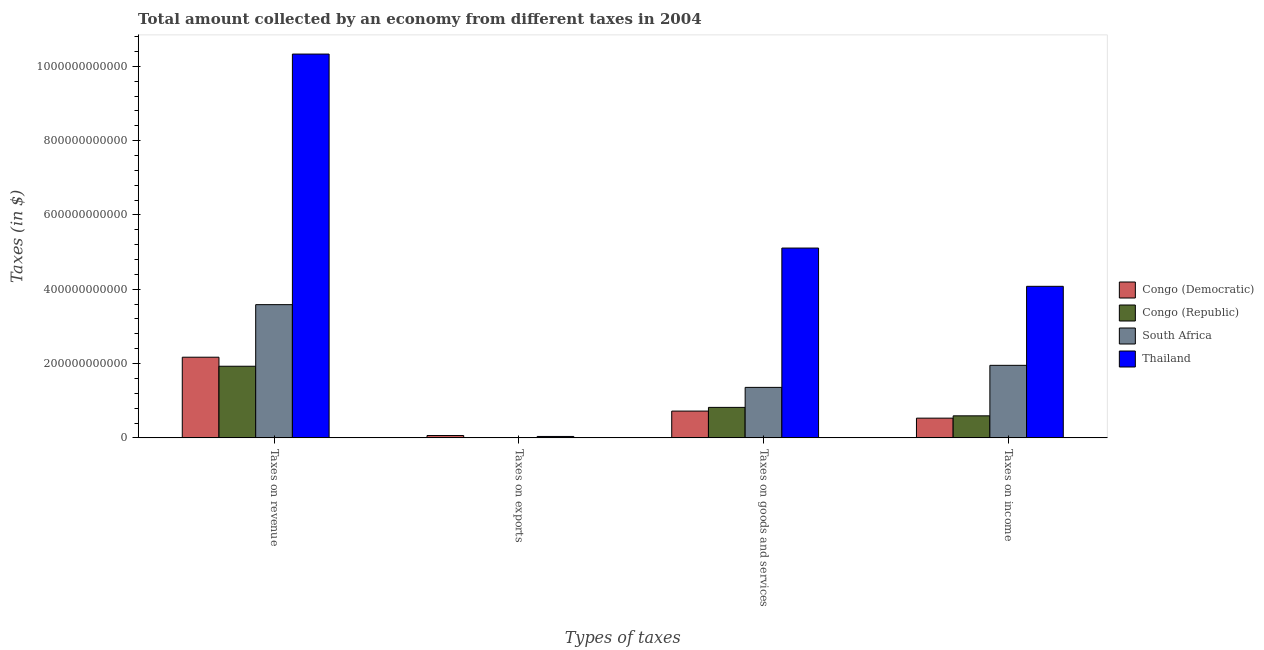How many different coloured bars are there?
Ensure brevity in your answer.  4. How many groups of bars are there?
Give a very brief answer. 4. Are the number of bars per tick equal to the number of legend labels?
Provide a short and direct response. Yes. How many bars are there on the 2nd tick from the left?
Keep it short and to the point. 4. How many bars are there on the 1st tick from the right?
Provide a short and direct response. 4. What is the label of the 3rd group of bars from the left?
Provide a succinct answer. Taxes on goods and services. What is the amount collected as tax on income in Congo (Democratic)?
Offer a terse response. 5.31e+1. Across all countries, what is the maximum amount collected as tax on goods?
Provide a short and direct response. 5.11e+11. Across all countries, what is the minimum amount collected as tax on income?
Ensure brevity in your answer.  5.31e+1. In which country was the amount collected as tax on income maximum?
Ensure brevity in your answer.  Thailand. In which country was the amount collected as tax on goods minimum?
Provide a short and direct response. Congo (Democratic). What is the total amount collected as tax on goods in the graph?
Provide a succinct answer. 8.01e+11. What is the difference between the amount collected as tax on exports in South Africa and that in Congo (Republic)?
Keep it short and to the point. -9.62e+07. What is the difference between the amount collected as tax on revenue in Congo (Democratic) and the amount collected as tax on exports in Thailand?
Offer a very short reply. 2.13e+11. What is the average amount collected as tax on goods per country?
Provide a succinct answer. 2.00e+11. What is the difference between the amount collected as tax on goods and amount collected as tax on revenue in Congo (Democratic)?
Keep it short and to the point. -1.45e+11. In how many countries, is the amount collected as tax on revenue greater than 360000000000 $?
Ensure brevity in your answer.  1. What is the ratio of the amount collected as tax on income in South Africa to that in Congo (Democratic)?
Provide a short and direct response. 3.68. Is the amount collected as tax on exports in Congo (Republic) less than that in Congo (Democratic)?
Make the answer very short. Yes. What is the difference between the highest and the second highest amount collected as tax on revenue?
Provide a succinct answer. 6.74e+11. What is the difference between the highest and the lowest amount collected as tax on goods?
Provide a short and direct response. 4.39e+11. In how many countries, is the amount collected as tax on income greater than the average amount collected as tax on income taken over all countries?
Offer a terse response. 2. Is it the case that in every country, the sum of the amount collected as tax on goods and amount collected as tax on revenue is greater than the sum of amount collected as tax on exports and amount collected as tax on income?
Your answer should be compact. Yes. What does the 2nd bar from the left in Taxes on exports represents?
Your response must be concise. Congo (Republic). What does the 2nd bar from the right in Taxes on exports represents?
Ensure brevity in your answer.  South Africa. Are all the bars in the graph horizontal?
Keep it short and to the point. No. How many countries are there in the graph?
Give a very brief answer. 4. What is the difference between two consecutive major ticks on the Y-axis?
Provide a succinct answer. 2.00e+11. Does the graph contain any zero values?
Provide a succinct answer. No. Does the graph contain grids?
Provide a succinct answer. No. Where does the legend appear in the graph?
Make the answer very short. Center right. How are the legend labels stacked?
Offer a very short reply. Vertical. What is the title of the graph?
Offer a very short reply. Total amount collected by an economy from different taxes in 2004. What is the label or title of the X-axis?
Ensure brevity in your answer.  Types of taxes. What is the label or title of the Y-axis?
Keep it short and to the point. Taxes (in $). What is the Taxes (in $) of Congo (Democratic) in Taxes on revenue?
Offer a terse response. 2.17e+11. What is the Taxes (in $) of Congo (Republic) in Taxes on revenue?
Keep it short and to the point. 1.93e+11. What is the Taxes (in $) of South Africa in Taxes on revenue?
Make the answer very short. 3.59e+11. What is the Taxes (in $) in Thailand in Taxes on revenue?
Your answer should be very brief. 1.03e+12. What is the Taxes (in $) of Congo (Democratic) in Taxes on exports?
Provide a succinct answer. 6.33e+09. What is the Taxes (in $) of Congo (Republic) in Taxes on exports?
Make the answer very short. 9.72e+07. What is the Taxes (in $) in South Africa in Taxes on exports?
Your answer should be very brief. 1.00e+06. What is the Taxes (in $) in Thailand in Taxes on exports?
Keep it short and to the point. 3.79e+09. What is the Taxes (in $) in Congo (Democratic) in Taxes on goods and services?
Offer a terse response. 7.21e+1. What is the Taxes (in $) of Congo (Republic) in Taxes on goods and services?
Offer a very short reply. 8.21e+1. What is the Taxes (in $) of South Africa in Taxes on goods and services?
Make the answer very short. 1.36e+11. What is the Taxes (in $) of Thailand in Taxes on goods and services?
Offer a very short reply. 5.11e+11. What is the Taxes (in $) in Congo (Democratic) in Taxes on income?
Provide a short and direct response. 5.31e+1. What is the Taxes (in $) of Congo (Republic) in Taxes on income?
Your response must be concise. 5.93e+1. What is the Taxes (in $) of South Africa in Taxes on income?
Your answer should be compact. 1.95e+11. What is the Taxes (in $) of Thailand in Taxes on income?
Provide a succinct answer. 4.08e+11. Across all Types of taxes, what is the maximum Taxes (in $) of Congo (Democratic)?
Your response must be concise. 2.17e+11. Across all Types of taxes, what is the maximum Taxes (in $) of Congo (Republic)?
Make the answer very short. 1.93e+11. Across all Types of taxes, what is the maximum Taxes (in $) in South Africa?
Your answer should be compact. 3.59e+11. Across all Types of taxes, what is the maximum Taxes (in $) in Thailand?
Make the answer very short. 1.03e+12. Across all Types of taxes, what is the minimum Taxes (in $) of Congo (Democratic)?
Your response must be concise. 6.33e+09. Across all Types of taxes, what is the minimum Taxes (in $) in Congo (Republic)?
Ensure brevity in your answer.  9.72e+07. Across all Types of taxes, what is the minimum Taxes (in $) of Thailand?
Your response must be concise. 3.79e+09. What is the total Taxes (in $) in Congo (Democratic) in the graph?
Provide a short and direct response. 3.49e+11. What is the total Taxes (in $) in Congo (Republic) in the graph?
Your response must be concise. 3.34e+11. What is the total Taxes (in $) of South Africa in the graph?
Offer a very short reply. 6.90e+11. What is the total Taxes (in $) in Thailand in the graph?
Your response must be concise. 1.96e+12. What is the difference between the Taxes (in $) of Congo (Democratic) in Taxes on revenue and that in Taxes on exports?
Provide a succinct answer. 2.11e+11. What is the difference between the Taxes (in $) in Congo (Republic) in Taxes on revenue and that in Taxes on exports?
Offer a terse response. 1.93e+11. What is the difference between the Taxes (in $) in South Africa in Taxes on revenue and that in Taxes on exports?
Provide a short and direct response. 3.59e+11. What is the difference between the Taxes (in $) in Thailand in Taxes on revenue and that in Taxes on exports?
Your answer should be very brief. 1.03e+12. What is the difference between the Taxes (in $) in Congo (Democratic) in Taxes on revenue and that in Taxes on goods and services?
Make the answer very short. 1.45e+11. What is the difference between the Taxes (in $) in Congo (Republic) in Taxes on revenue and that in Taxes on goods and services?
Ensure brevity in your answer.  1.11e+11. What is the difference between the Taxes (in $) of South Africa in Taxes on revenue and that in Taxes on goods and services?
Offer a very short reply. 2.23e+11. What is the difference between the Taxes (in $) of Thailand in Taxes on revenue and that in Taxes on goods and services?
Offer a terse response. 5.22e+11. What is the difference between the Taxes (in $) in Congo (Democratic) in Taxes on revenue and that in Taxes on income?
Provide a short and direct response. 1.64e+11. What is the difference between the Taxes (in $) in Congo (Republic) in Taxes on revenue and that in Taxes on income?
Offer a terse response. 1.33e+11. What is the difference between the Taxes (in $) of South Africa in Taxes on revenue and that in Taxes on income?
Provide a short and direct response. 1.63e+11. What is the difference between the Taxes (in $) in Thailand in Taxes on revenue and that in Taxes on income?
Provide a succinct answer. 6.25e+11. What is the difference between the Taxes (in $) of Congo (Democratic) in Taxes on exports and that in Taxes on goods and services?
Your response must be concise. -6.58e+1. What is the difference between the Taxes (in $) of Congo (Republic) in Taxes on exports and that in Taxes on goods and services?
Your answer should be very brief. -8.20e+1. What is the difference between the Taxes (in $) of South Africa in Taxes on exports and that in Taxes on goods and services?
Offer a very short reply. -1.36e+11. What is the difference between the Taxes (in $) of Thailand in Taxes on exports and that in Taxes on goods and services?
Ensure brevity in your answer.  -5.07e+11. What is the difference between the Taxes (in $) of Congo (Democratic) in Taxes on exports and that in Taxes on income?
Offer a very short reply. -4.68e+1. What is the difference between the Taxes (in $) of Congo (Republic) in Taxes on exports and that in Taxes on income?
Offer a very short reply. -5.92e+1. What is the difference between the Taxes (in $) in South Africa in Taxes on exports and that in Taxes on income?
Provide a succinct answer. -1.95e+11. What is the difference between the Taxes (in $) in Thailand in Taxes on exports and that in Taxes on income?
Provide a succinct answer. -4.04e+11. What is the difference between the Taxes (in $) of Congo (Democratic) in Taxes on goods and services and that in Taxes on income?
Offer a terse response. 1.90e+1. What is the difference between the Taxes (in $) of Congo (Republic) in Taxes on goods and services and that in Taxes on income?
Provide a short and direct response. 2.28e+1. What is the difference between the Taxes (in $) of South Africa in Taxes on goods and services and that in Taxes on income?
Your answer should be very brief. -5.94e+1. What is the difference between the Taxes (in $) in Thailand in Taxes on goods and services and that in Taxes on income?
Your answer should be very brief. 1.03e+11. What is the difference between the Taxes (in $) of Congo (Democratic) in Taxes on revenue and the Taxes (in $) of Congo (Republic) in Taxes on exports?
Give a very brief answer. 2.17e+11. What is the difference between the Taxes (in $) of Congo (Democratic) in Taxes on revenue and the Taxes (in $) of South Africa in Taxes on exports?
Your answer should be compact. 2.17e+11. What is the difference between the Taxes (in $) in Congo (Democratic) in Taxes on revenue and the Taxes (in $) in Thailand in Taxes on exports?
Your answer should be compact. 2.13e+11. What is the difference between the Taxes (in $) in Congo (Republic) in Taxes on revenue and the Taxes (in $) in South Africa in Taxes on exports?
Offer a terse response. 1.93e+11. What is the difference between the Taxes (in $) in Congo (Republic) in Taxes on revenue and the Taxes (in $) in Thailand in Taxes on exports?
Provide a succinct answer. 1.89e+11. What is the difference between the Taxes (in $) in South Africa in Taxes on revenue and the Taxes (in $) in Thailand in Taxes on exports?
Give a very brief answer. 3.55e+11. What is the difference between the Taxes (in $) in Congo (Democratic) in Taxes on revenue and the Taxes (in $) in Congo (Republic) in Taxes on goods and services?
Give a very brief answer. 1.35e+11. What is the difference between the Taxes (in $) in Congo (Democratic) in Taxes on revenue and the Taxes (in $) in South Africa in Taxes on goods and services?
Keep it short and to the point. 8.12e+1. What is the difference between the Taxes (in $) of Congo (Democratic) in Taxes on revenue and the Taxes (in $) of Thailand in Taxes on goods and services?
Give a very brief answer. -2.94e+11. What is the difference between the Taxes (in $) in Congo (Republic) in Taxes on revenue and the Taxes (in $) in South Africa in Taxes on goods and services?
Ensure brevity in your answer.  5.69e+1. What is the difference between the Taxes (in $) in Congo (Republic) in Taxes on revenue and the Taxes (in $) in Thailand in Taxes on goods and services?
Provide a short and direct response. -3.18e+11. What is the difference between the Taxes (in $) in South Africa in Taxes on revenue and the Taxes (in $) in Thailand in Taxes on goods and services?
Provide a short and direct response. -1.52e+11. What is the difference between the Taxes (in $) in Congo (Democratic) in Taxes on revenue and the Taxes (in $) in Congo (Republic) in Taxes on income?
Give a very brief answer. 1.58e+11. What is the difference between the Taxes (in $) of Congo (Democratic) in Taxes on revenue and the Taxes (in $) of South Africa in Taxes on income?
Your answer should be very brief. 2.18e+1. What is the difference between the Taxes (in $) in Congo (Democratic) in Taxes on revenue and the Taxes (in $) in Thailand in Taxes on income?
Keep it short and to the point. -1.91e+11. What is the difference between the Taxes (in $) of Congo (Republic) in Taxes on revenue and the Taxes (in $) of South Africa in Taxes on income?
Offer a terse response. -2.46e+09. What is the difference between the Taxes (in $) of Congo (Republic) in Taxes on revenue and the Taxes (in $) of Thailand in Taxes on income?
Provide a short and direct response. -2.15e+11. What is the difference between the Taxes (in $) of South Africa in Taxes on revenue and the Taxes (in $) of Thailand in Taxes on income?
Give a very brief answer. -4.93e+1. What is the difference between the Taxes (in $) in Congo (Democratic) in Taxes on exports and the Taxes (in $) in Congo (Republic) in Taxes on goods and services?
Your answer should be compact. -7.57e+1. What is the difference between the Taxes (in $) in Congo (Democratic) in Taxes on exports and the Taxes (in $) in South Africa in Taxes on goods and services?
Your response must be concise. -1.30e+11. What is the difference between the Taxes (in $) in Congo (Democratic) in Taxes on exports and the Taxes (in $) in Thailand in Taxes on goods and services?
Make the answer very short. -5.05e+11. What is the difference between the Taxes (in $) in Congo (Republic) in Taxes on exports and the Taxes (in $) in South Africa in Taxes on goods and services?
Offer a terse response. -1.36e+11. What is the difference between the Taxes (in $) in Congo (Republic) in Taxes on exports and the Taxes (in $) in Thailand in Taxes on goods and services?
Provide a short and direct response. -5.11e+11. What is the difference between the Taxes (in $) in South Africa in Taxes on exports and the Taxes (in $) in Thailand in Taxes on goods and services?
Your answer should be very brief. -5.11e+11. What is the difference between the Taxes (in $) of Congo (Democratic) in Taxes on exports and the Taxes (in $) of Congo (Republic) in Taxes on income?
Give a very brief answer. -5.30e+1. What is the difference between the Taxes (in $) in Congo (Democratic) in Taxes on exports and the Taxes (in $) in South Africa in Taxes on income?
Provide a succinct answer. -1.89e+11. What is the difference between the Taxes (in $) of Congo (Democratic) in Taxes on exports and the Taxes (in $) of Thailand in Taxes on income?
Your answer should be very brief. -4.02e+11. What is the difference between the Taxes (in $) in Congo (Republic) in Taxes on exports and the Taxes (in $) in South Africa in Taxes on income?
Keep it short and to the point. -1.95e+11. What is the difference between the Taxes (in $) in Congo (Republic) in Taxes on exports and the Taxes (in $) in Thailand in Taxes on income?
Offer a terse response. -4.08e+11. What is the difference between the Taxes (in $) of South Africa in Taxes on exports and the Taxes (in $) of Thailand in Taxes on income?
Keep it short and to the point. -4.08e+11. What is the difference between the Taxes (in $) of Congo (Democratic) in Taxes on goods and services and the Taxes (in $) of Congo (Republic) in Taxes on income?
Provide a succinct answer. 1.28e+1. What is the difference between the Taxes (in $) in Congo (Democratic) in Taxes on goods and services and the Taxes (in $) in South Africa in Taxes on income?
Offer a very short reply. -1.23e+11. What is the difference between the Taxes (in $) of Congo (Democratic) in Taxes on goods and services and the Taxes (in $) of Thailand in Taxes on income?
Your answer should be very brief. -3.36e+11. What is the difference between the Taxes (in $) of Congo (Republic) in Taxes on goods and services and the Taxes (in $) of South Africa in Taxes on income?
Offer a terse response. -1.13e+11. What is the difference between the Taxes (in $) of Congo (Republic) in Taxes on goods and services and the Taxes (in $) of Thailand in Taxes on income?
Make the answer very short. -3.26e+11. What is the difference between the Taxes (in $) in South Africa in Taxes on goods and services and the Taxes (in $) in Thailand in Taxes on income?
Provide a short and direct response. -2.72e+11. What is the average Taxes (in $) of Congo (Democratic) per Types of taxes?
Make the answer very short. 8.71e+1. What is the average Taxes (in $) of Congo (Republic) per Types of taxes?
Provide a short and direct response. 8.36e+1. What is the average Taxes (in $) of South Africa per Types of taxes?
Make the answer very short. 1.72e+11. What is the average Taxes (in $) in Thailand per Types of taxes?
Give a very brief answer. 4.89e+11. What is the difference between the Taxes (in $) in Congo (Democratic) and Taxes (in $) in Congo (Republic) in Taxes on revenue?
Offer a very short reply. 2.43e+1. What is the difference between the Taxes (in $) of Congo (Democratic) and Taxes (in $) of South Africa in Taxes on revenue?
Offer a very short reply. -1.41e+11. What is the difference between the Taxes (in $) in Congo (Democratic) and Taxes (in $) in Thailand in Taxes on revenue?
Your answer should be very brief. -8.16e+11. What is the difference between the Taxes (in $) in Congo (Republic) and Taxes (in $) in South Africa in Taxes on revenue?
Make the answer very short. -1.66e+11. What is the difference between the Taxes (in $) in Congo (Republic) and Taxes (in $) in Thailand in Taxes on revenue?
Make the answer very short. -8.40e+11. What is the difference between the Taxes (in $) in South Africa and Taxes (in $) in Thailand in Taxes on revenue?
Ensure brevity in your answer.  -6.74e+11. What is the difference between the Taxes (in $) of Congo (Democratic) and Taxes (in $) of Congo (Republic) in Taxes on exports?
Provide a succinct answer. 6.23e+09. What is the difference between the Taxes (in $) in Congo (Democratic) and Taxes (in $) in South Africa in Taxes on exports?
Your response must be concise. 6.32e+09. What is the difference between the Taxes (in $) of Congo (Democratic) and Taxes (in $) of Thailand in Taxes on exports?
Offer a very short reply. 2.54e+09. What is the difference between the Taxes (in $) of Congo (Republic) and Taxes (in $) of South Africa in Taxes on exports?
Offer a terse response. 9.62e+07. What is the difference between the Taxes (in $) of Congo (Republic) and Taxes (in $) of Thailand in Taxes on exports?
Your answer should be compact. -3.69e+09. What is the difference between the Taxes (in $) of South Africa and Taxes (in $) of Thailand in Taxes on exports?
Make the answer very short. -3.79e+09. What is the difference between the Taxes (in $) of Congo (Democratic) and Taxes (in $) of Congo (Republic) in Taxes on goods and services?
Ensure brevity in your answer.  -9.97e+09. What is the difference between the Taxes (in $) of Congo (Democratic) and Taxes (in $) of South Africa in Taxes on goods and services?
Make the answer very short. -6.38e+1. What is the difference between the Taxes (in $) of Congo (Democratic) and Taxes (in $) of Thailand in Taxes on goods and services?
Your answer should be compact. -4.39e+11. What is the difference between the Taxes (in $) of Congo (Republic) and Taxes (in $) of South Africa in Taxes on goods and services?
Provide a short and direct response. -5.38e+1. What is the difference between the Taxes (in $) of Congo (Republic) and Taxes (in $) of Thailand in Taxes on goods and services?
Provide a succinct answer. -4.29e+11. What is the difference between the Taxes (in $) in South Africa and Taxes (in $) in Thailand in Taxes on goods and services?
Keep it short and to the point. -3.75e+11. What is the difference between the Taxes (in $) of Congo (Democratic) and Taxes (in $) of Congo (Republic) in Taxes on income?
Ensure brevity in your answer.  -6.23e+09. What is the difference between the Taxes (in $) in Congo (Democratic) and Taxes (in $) in South Africa in Taxes on income?
Offer a terse response. -1.42e+11. What is the difference between the Taxes (in $) in Congo (Democratic) and Taxes (in $) in Thailand in Taxes on income?
Give a very brief answer. -3.55e+11. What is the difference between the Taxes (in $) of Congo (Republic) and Taxes (in $) of South Africa in Taxes on income?
Ensure brevity in your answer.  -1.36e+11. What is the difference between the Taxes (in $) in Congo (Republic) and Taxes (in $) in Thailand in Taxes on income?
Provide a succinct answer. -3.49e+11. What is the difference between the Taxes (in $) in South Africa and Taxes (in $) in Thailand in Taxes on income?
Your response must be concise. -2.13e+11. What is the ratio of the Taxes (in $) in Congo (Democratic) in Taxes on revenue to that in Taxes on exports?
Your response must be concise. 34.32. What is the ratio of the Taxes (in $) of Congo (Republic) in Taxes on revenue to that in Taxes on exports?
Offer a very short reply. 1983.41. What is the ratio of the Taxes (in $) of South Africa in Taxes on revenue to that in Taxes on exports?
Your answer should be compact. 3.59e+05. What is the ratio of the Taxes (in $) in Thailand in Taxes on revenue to that in Taxes on exports?
Make the answer very short. 272.75. What is the ratio of the Taxes (in $) in Congo (Democratic) in Taxes on revenue to that in Taxes on goods and services?
Give a very brief answer. 3.01. What is the ratio of the Taxes (in $) of Congo (Republic) in Taxes on revenue to that in Taxes on goods and services?
Your answer should be very brief. 2.35. What is the ratio of the Taxes (in $) in South Africa in Taxes on revenue to that in Taxes on goods and services?
Your answer should be compact. 2.64. What is the ratio of the Taxes (in $) in Thailand in Taxes on revenue to that in Taxes on goods and services?
Keep it short and to the point. 2.02. What is the ratio of the Taxes (in $) in Congo (Democratic) in Taxes on revenue to that in Taxes on income?
Provide a short and direct response. 4.09. What is the ratio of the Taxes (in $) in Congo (Republic) in Taxes on revenue to that in Taxes on income?
Your answer should be very brief. 3.25. What is the ratio of the Taxes (in $) of South Africa in Taxes on revenue to that in Taxes on income?
Your answer should be very brief. 1.84. What is the ratio of the Taxes (in $) in Thailand in Taxes on revenue to that in Taxes on income?
Your response must be concise. 2.53. What is the ratio of the Taxes (in $) of Congo (Democratic) in Taxes on exports to that in Taxes on goods and services?
Your answer should be compact. 0.09. What is the ratio of the Taxes (in $) of Congo (Republic) in Taxes on exports to that in Taxes on goods and services?
Your answer should be very brief. 0. What is the ratio of the Taxes (in $) in Thailand in Taxes on exports to that in Taxes on goods and services?
Provide a succinct answer. 0.01. What is the ratio of the Taxes (in $) of Congo (Democratic) in Taxes on exports to that in Taxes on income?
Make the answer very short. 0.12. What is the ratio of the Taxes (in $) in Congo (Republic) in Taxes on exports to that in Taxes on income?
Offer a terse response. 0. What is the ratio of the Taxes (in $) in Thailand in Taxes on exports to that in Taxes on income?
Provide a succinct answer. 0.01. What is the ratio of the Taxes (in $) of Congo (Democratic) in Taxes on goods and services to that in Taxes on income?
Keep it short and to the point. 1.36. What is the ratio of the Taxes (in $) of Congo (Republic) in Taxes on goods and services to that in Taxes on income?
Provide a short and direct response. 1.38. What is the ratio of the Taxes (in $) of South Africa in Taxes on goods and services to that in Taxes on income?
Keep it short and to the point. 0.7. What is the ratio of the Taxes (in $) of Thailand in Taxes on goods and services to that in Taxes on income?
Your answer should be very brief. 1.25. What is the difference between the highest and the second highest Taxes (in $) in Congo (Democratic)?
Offer a terse response. 1.45e+11. What is the difference between the highest and the second highest Taxes (in $) in Congo (Republic)?
Provide a succinct answer. 1.11e+11. What is the difference between the highest and the second highest Taxes (in $) in South Africa?
Give a very brief answer. 1.63e+11. What is the difference between the highest and the second highest Taxes (in $) of Thailand?
Your answer should be very brief. 5.22e+11. What is the difference between the highest and the lowest Taxes (in $) of Congo (Democratic)?
Your answer should be very brief. 2.11e+11. What is the difference between the highest and the lowest Taxes (in $) of Congo (Republic)?
Your answer should be very brief. 1.93e+11. What is the difference between the highest and the lowest Taxes (in $) of South Africa?
Your response must be concise. 3.59e+11. What is the difference between the highest and the lowest Taxes (in $) in Thailand?
Offer a very short reply. 1.03e+12. 